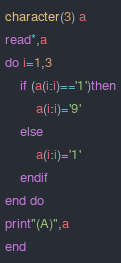Convert code to text. <code><loc_0><loc_0><loc_500><loc_500><_FORTRAN_>character(3) a
read*,a
do i=1,3
	if (a(i:i)=='1')then
    	a(i:i)='9'
    else
    	a(i:i)='1'
    endif
end do
print"(A)",a
end</code> 